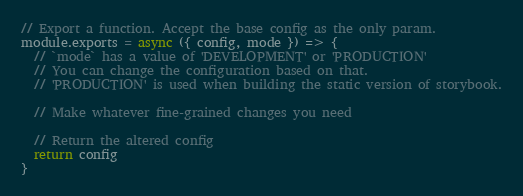Convert code to text. <code><loc_0><loc_0><loc_500><loc_500><_JavaScript_>// Export a function. Accept the base config as the only param.
module.exports = async ({ config, mode }) => {
  // `mode` has a value of 'DEVELOPMENT' or 'PRODUCTION'
  // You can change the configuration based on that.
  // 'PRODUCTION' is used when building the static version of storybook.

  // Make whatever fine-grained changes you need

  // Return the altered config
  return config
}
</code> 